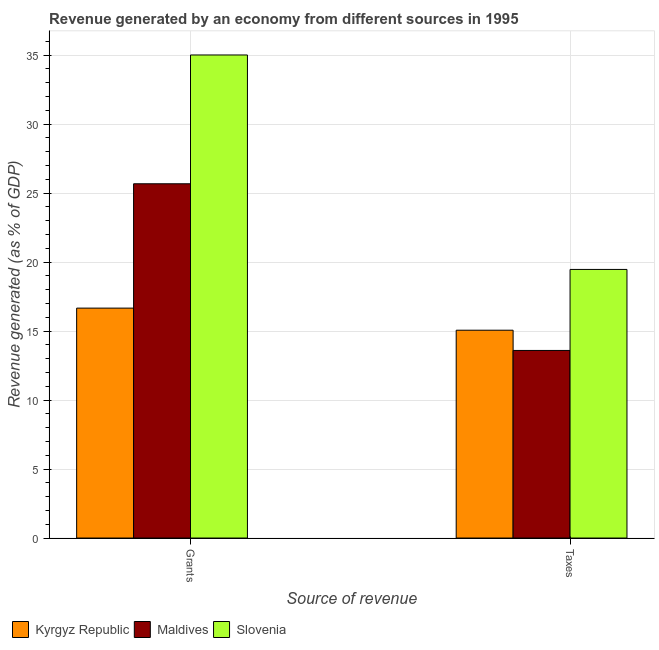How many different coloured bars are there?
Your response must be concise. 3. What is the label of the 2nd group of bars from the left?
Give a very brief answer. Taxes. What is the revenue generated by taxes in Slovenia?
Offer a very short reply. 19.47. Across all countries, what is the maximum revenue generated by grants?
Make the answer very short. 35.01. Across all countries, what is the minimum revenue generated by taxes?
Ensure brevity in your answer.  13.6. In which country was the revenue generated by taxes maximum?
Offer a very short reply. Slovenia. In which country was the revenue generated by taxes minimum?
Make the answer very short. Maldives. What is the total revenue generated by grants in the graph?
Provide a succinct answer. 77.35. What is the difference between the revenue generated by grants in Maldives and that in Kyrgyz Republic?
Offer a terse response. 9.01. What is the difference between the revenue generated by grants in Kyrgyz Republic and the revenue generated by taxes in Maldives?
Provide a short and direct response. 3.07. What is the average revenue generated by grants per country?
Provide a short and direct response. 25.78. What is the difference between the revenue generated by grants and revenue generated by taxes in Slovenia?
Keep it short and to the point. 15.54. What is the ratio of the revenue generated by taxes in Kyrgyz Republic to that in Slovenia?
Your answer should be very brief. 0.77. What does the 1st bar from the left in Taxes represents?
Give a very brief answer. Kyrgyz Republic. What does the 1st bar from the right in Grants represents?
Give a very brief answer. Slovenia. How many bars are there?
Offer a very short reply. 6. How many countries are there in the graph?
Offer a very short reply. 3. Are the values on the major ticks of Y-axis written in scientific E-notation?
Offer a very short reply. No. What is the title of the graph?
Offer a very short reply. Revenue generated by an economy from different sources in 1995. What is the label or title of the X-axis?
Offer a terse response. Source of revenue. What is the label or title of the Y-axis?
Your answer should be compact. Revenue generated (as % of GDP). What is the Revenue generated (as % of GDP) of Kyrgyz Republic in Grants?
Ensure brevity in your answer.  16.67. What is the Revenue generated (as % of GDP) in Maldives in Grants?
Provide a succinct answer. 25.68. What is the Revenue generated (as % of GDP) in Slovenia in Grants?
Make the answer very short. 35.01. What is the Revenue generated (as % of GDP) in Kyrgyz Republic in Taxes?
Offer a terse response. 15.06. What is the Revenue generated (as % of GDP) in Maldives in Taxes?
Keep it short and to the point. 13.6. What is the Revenue generated (as % of GDP) in Slovenia in Taxes?
Ensure brevity in your answer.  19.47. Across all Source of revenue, what is the maximum Revenue generated (as % of GDP) of Kyrgyz Republic?
Make the answer very short. 16.67. Across all Source of revenue, what is the maximum Revenue generated (as % of GDP) of Maldives?
Your response must be concise. 25.68. Across all Source of revenue, what is the maximum Revenue generated (as % of GDP) in Slovenia?
Offer a terse response. 35.01. Across all Source of revenue, what is the minimum Revenue generated (as % of GDP) in Kyrgyz Republic?
Provide a succinct answer. 15.06. Across all Source of revenue, what is the minimum Revenue generated (as % of GDP) of Maldives?
Make the answer very short. 13.6. Across all Source of revenue, what is the minimum Revenue generated (as % of GDP) of Slovenia?
Provide a short and direct response. 19.47. What is the total Revenue generated (as % of GDP) of Kyrgyz Republic in the graph?
Ensure brevity in your answer.  31.73. What is the total Revenue generated (as % of GDP) of Maldives in the graph?
Your answer should be very brief. 39.27. What is the total Revenue generated (as % of GDP) of Slovenia in the graph?
Ensure brevity in your answer.  54.48. What is the difference between the Revenue generated (as % of GDP) of Kyrgyz Republic in Grants and that in Taxes?
Provide a succinct answer. 1.6. What is the difference between the Revenue generated (as % of GDP) of Maldives in Grants and that in Taxes?
Make the answer very short. 12.08. What is the difference between the Revenue generated (as % of GDP) of Slovenia in Grants and that in Taxes?
Your answer should be very brief. 15.54. What is the difference between the Revenue generated (as % of GDP) in Kyrgyz Republic in Grants and the Revenue generated (as % of GDP) in Maldives in Taxes?
Your answer should be very brief. 3.07. What is the difference between the Revenue generated (as % of GDP) in Kyrgyz Republic in Grants and the Revenue generated (as % of GDP) in Slovenia in Taxes?
Offer a very short reply. -2.8. What is the difference between the Revenue generated (as % of GDP) in Maldives in Grants and the Revenue generated (as % of GDP) in Slovenia in Taxes?
Offer a very short reply. 6.21. What is the average Revenue generated (as % of GDP) in Kyrgyz Republic per Source of revenue?
Provide a short and direct response. 15.86. What is the average Revenue generated (as % of GDP) in Maldives per Source of revenue?
Your answer should be compact. 19.64. What is the average Revenue generated (as % of GDP) in Slovenia per Source of revenue?
Provide a short and direct response. 27.24. What is the difference between the Revenue generated (as % of GDP) of Kyrgyz Republic and Revenue generated (as % of GDP) of Maldives in Grants?
Your answer should be very brief. -9.01. What is the difference between the Revenue generated (as % of GDP) in Kyrgyz Republic and Revenue generated (as % of GDP) in Slovenia in Grants?
Ensure brevity in your answer.  -18.35. What is the difference between the Revenue generated (as % of GDP) of Maldives and Revenue generated (as % of GDP) of Slovenia in Grants?
Make the answer very short. -9.34. What is the difference between the Revenue generated (as % of GDP) of Kyrgyz Republic and Revenue generated (as % of GDP) of Maldives in Taxes?
Make the answer very short. 1.47. What is the difference between the Revenue generated (as % of GDP) in Kyrgyz Republic and Revenue generated (as % of GDP) in Slovenia in Taxes?
Provide a short and direct response. -4.41. What is the difference between the Revenue generated (as % of GDP) of Maldives and Revenue generated (as % of GDP) of Slovenia in Taxes?
Give a very brief answer. -5.87. What is the ratio of the Revenue generated (as % of GDP) of Kyrgyz Republic in Grants to that in Taxes?
Your response must be concise. 1.11. What is the ratio of the Revenue generated (as % of GDP) in Maldives in Grants to that in Taxes?
Keep it short and to the point. 1.89. What is the ratio of the Revenue generated (as % of GDP) in Slovenia in Grants to that in Taxes?
Offer a very short reply. 1.8. What is the difference between the highest and the second highest Revenue generated (as % of GDP) in Kyrgyz Republic?
Offer a very short reply. 1.6. What is the difference between the highest and the second highest Revenue generated (as % of GDP) of Maldives?
Your response must be concise. 12.08. What is the difference between the highest and the second highest Revenue generated (as % of GDP) of Slovenia?
Ensure brevity in your answer.  15.54. What is the difference between the highest and the lowest Revenue generated (as % of GDP) in Kyrgyz Republic?
Give a very brief answer. 1.6. What is the difference between the highest and the lowest Revenue generated (as % of GDP) in Maldives?
Give a very brief answer. 12.08. What is the difference between the highest and the lowest Revenue generated (as % of GDP) in Slovenia?
Provide a succinct answer. 15.54. 